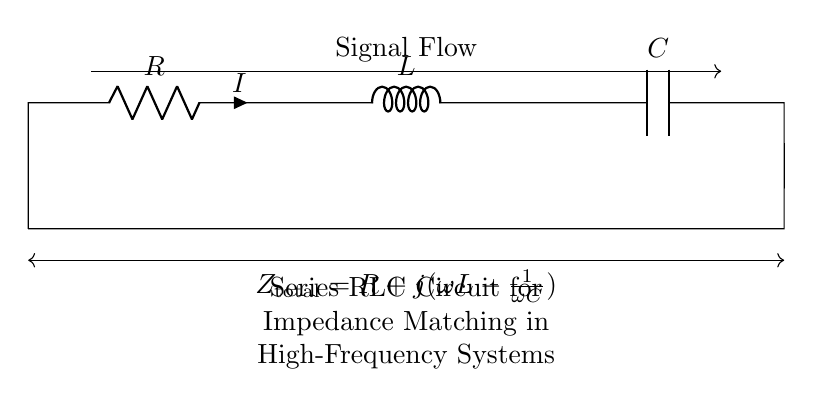What components are present in this circuit? The diagram shows a resistor, an inductor, and a capacitor arranged in series. These are the key components of the RLC circuit configuration.
Answer: Resistor, Inductor, Capacitor What is the total impedance formula for this circuit? The total impedance is given as R plus the imaginary part of the inductive reactance minus the capacitive reactance. This is mathematically represented as R + j(ωL - 1/ωC).
Answer: R + j(ωL - 1/ωC) How does the impedance of this circuit change with frequency? The impedance changes with frequency due to the frequency dependence of the inductor and capacitor's reactances. As frequency increases, the inductive reactance increases while the capacitive reactance decreases, affecting the total impedance.
Answer: Frequency-dependent What is the purpose of using a series RLC circuit for impedance matching? The series RLC circuit is used for impedance matching to maximize power transfer and minimize reflection within high-frequency communication systems. This is critical for effective signal transmission.
Answer: Impedance matching Which component is responsible for phase shift in the circuit? The inductor contributes to a positive phase shift while the capacitor contributes to a negative phase shift, causing overall phase alterations depending on values chosen.
Answer: Inductor and Capacitor What is the condition for resonance in this circuit? Resonance occurs when the inductive reactance equals the capacitive reactance, or mathematically when ωL = 1/ωC, leading to maximum current flow through the circuit.
Answer: ωL = 1/ωC 